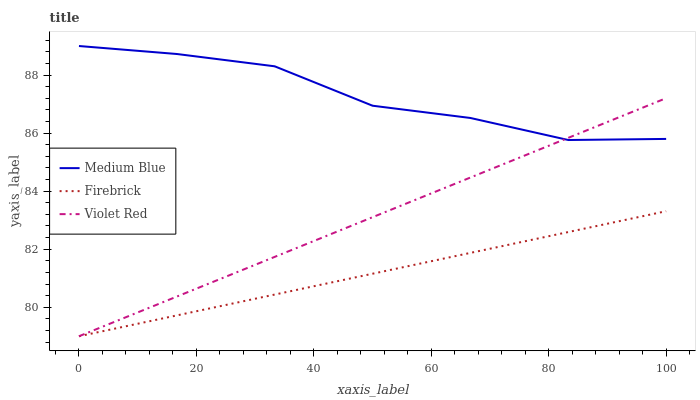Does Firebrick have the minimum area under the curve?
Answer yes or no. Yes. Does Medium Blue have the maximum area under the curve?
Answer yes or no. Yes. Does Violet Red have the minimum area under the curve?
Answer yes or no. No. Does Violet Red have the maximum area under the curve?
Answer yes or no. No. Is Firebrick the smoothest?
Answer yes or no. Yes. Is Medium Blue the roughest?
Answer yes or no. Yes. Is Violet Red the smoothest?
Answer yes or no. No. Is Violet Red the roughest?
Answer yes or no. No. Does Firebrick have the lowest value?
Answer yes or no. Yes. Does Medium Blue have the lowest value?
Answer yes or no. No. Does Medium Blue have the highest value?
Answer yes or no. Yes. Does Violet Red have the highest value?
Answer yes or no. No. Is Firebrick less than Medium Blue?
Answer yes or no. Yes. Is Medium Blue greater than Firebrick?
Answer yes or no. Yes. Does Medium Blue intersect Violet Red?
Answer yes or no. Yes. Is Medium Blue less than Violet Red?
Answer yes or no. No. Is Medium Blue greater than Violet Red?
Answer yes or no. No. Does Firebrick intersect Medium Blue?
Answer yes or no. No. 